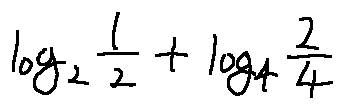Convert formula to latex. <formula><loc_0><loc_0><loc_500><loc_500>\log _ { 2 } \frac { 1 } { 2 } + \log _ { 4 } \frac { 2 } { 4 }</formula> 